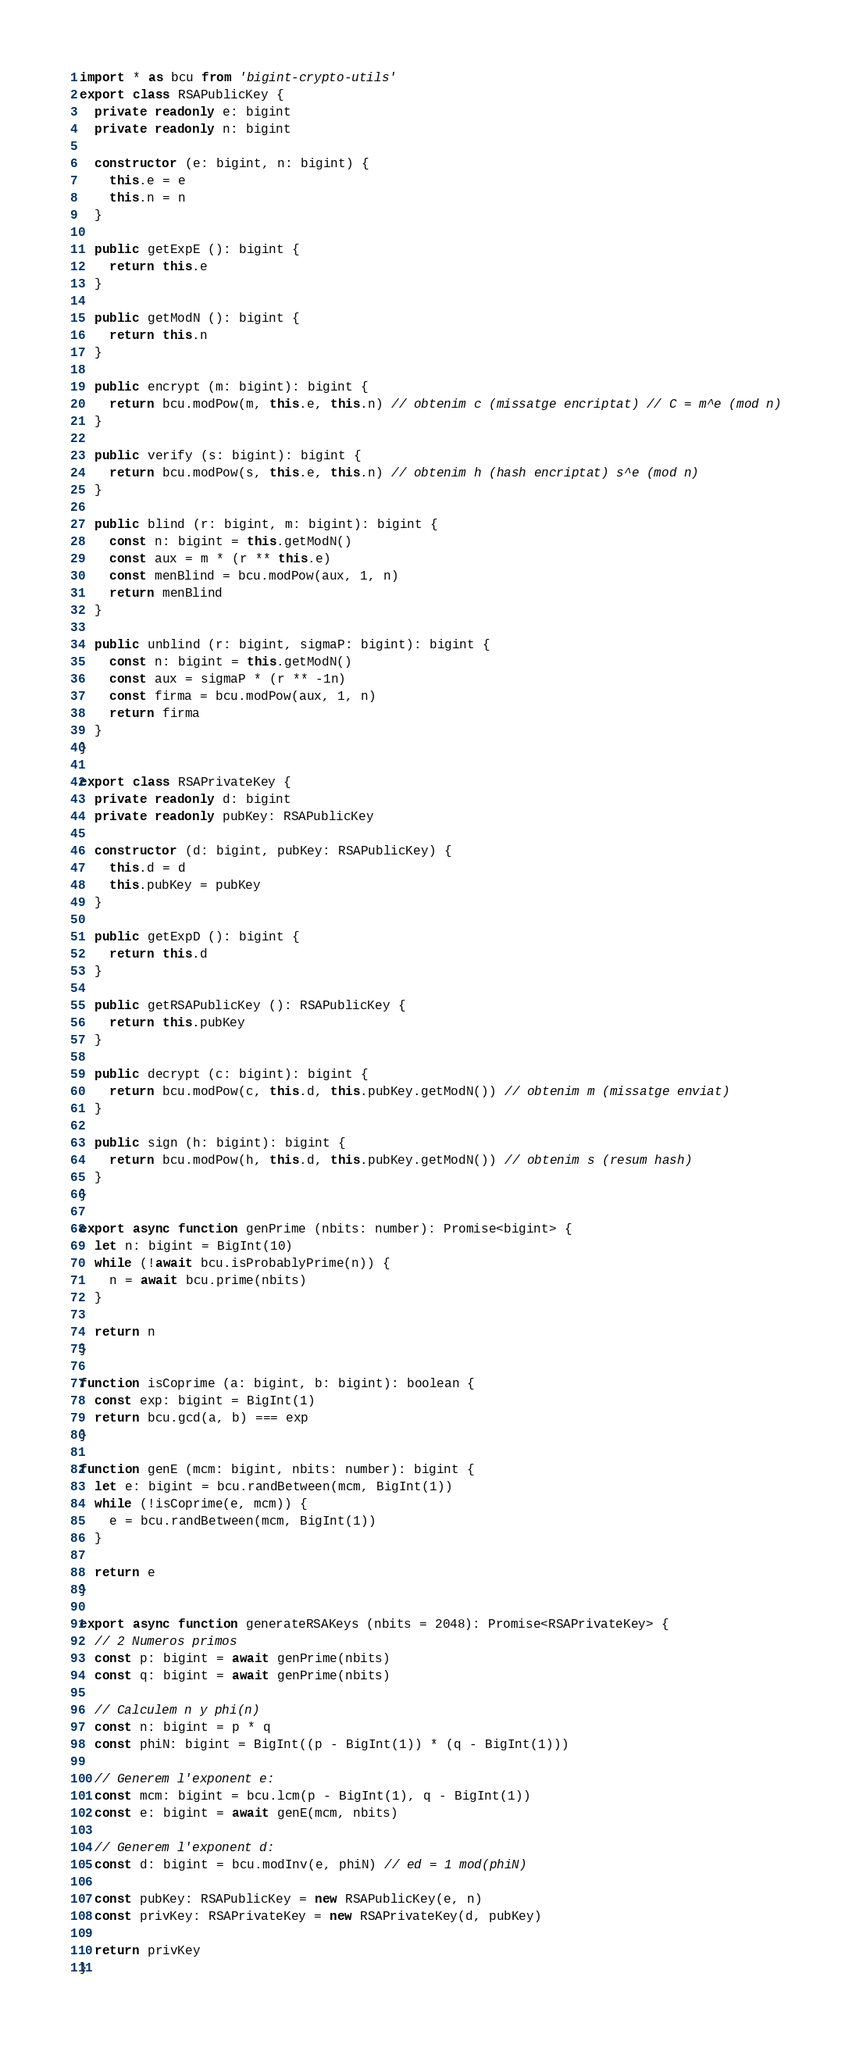<code> <loc_0><loc_0><loc_500><loc_500><_TypeScript_>import * as bcu from 'bigint-crypto-utils'
export class RSAPublicKey {
  private readonly e: bigint
  private readonly n: bigint

  constructor (e: bigint, n: bigint) {
    this.e = e
    this.n = n
  }

  public getExpE (): bigint {
    return this.e
  }

  public getModN (): bigint {
    return this.n
  }

  public encrypt (m: bigint): bigint {
    return bcu.modPow(m, this.e, this.n) // obtenim c (missatge encriptat) // C = m^e (mod n)
  }

  public verify (s: bigint): bigint {
    return bcu.modPow(s, this.e, this.n) // obtenim h (hash encriptat) s^e (mod n)
  }

  public blind (r: bigint, m: bigint): bigint {
    const n: bigint = this.getModN()
    const aux = m * (r ** this.e)
    const menBlind = bcu.modPow(aux, 1, n)
    return menBlind
  }

  public unblind (r: bigint, sigmaP: bigint): bigint {
    const n: bigint = this.getModN()
    const aux = sigmaP * (r ** -1n)
    const firma = bcu.modPow(aux, 1, n)
    return firma
  }
}

export class RSAPrivateKey {
  private readonly d: bigint
  private readonly pubKey: RSAPublicKey

  constructor (d: bigint, pubKey: RSAPublicKey) {
    this.d = d
    this.pubKey = pubKey
  }

  public getExpD (): bigint {
    return this.d
  }

  public getRSAPublicKey (): RSAPublicKey {
    return this.pubKey
  }

  public decrypt (c: bigint): bigint {
    return bcu.modPow(c, this.d, this.pubKey.getModN()) // obtenim m (missatge enviat)
  }

  public sign (h: bigint): bigint {
    return bcu.modPow(h, this.d, this.pubKey.getModN()) // obtenim s (resum hash)
  }
}

export async function genPrime (nbits: number): Promise<bigint> {
  let n: bigint = BigInt(10)
  while (!await bcu.isProbablyPrime(n)) {
    n = await bcu.prime(nbits)
  }

  return n
}

function isCoprime (a: bigint, b: bigint): boolean {
  const exp: bigint = BigInt(1)
  return bcu.gcd(a, b) === exp
}

function genE (mcm: bigint, nbits: number): bigint {
  let e: bigint = bcu.randBetween(mcm, BigInt(1))
  while (!isCoprime(e, mcm)) {
    e = bcu.randBetween(mcm, BigInt(1))
  }

  return e
}

export async function generateRSAKeys (nbits = 2048): Promise<RSAPrivateKey> {
  // 2 Numeros primos
  const p: bigint = await genPrime(nbits)
  const q: bigint = await genPrime(nbits)

  // Calculem n y phi(n)
  const n: bigint = p * q
  const phiN: bigint = BigInt((p - BigInt(1)) * (q - BigInt(1)))

  // Generem l'exponent e:
  const mcm: bigint = bcu.lcm(p - BigInt(1), q - BigInt(1))
  const e: bigint = await genE(mcm, nbits)

  // Generem l'exponent d:
  const d: bigint = bcu.modInv(e, phiN) // ed = 1 mod(phiN)

  const pubKey: RSAPublicKey = new RSAPublicKey(e, n)
  const privKey: RSAPrivateKey = new RSAPrivateKey(d, pubKey)

  return privKey
}
</code> 